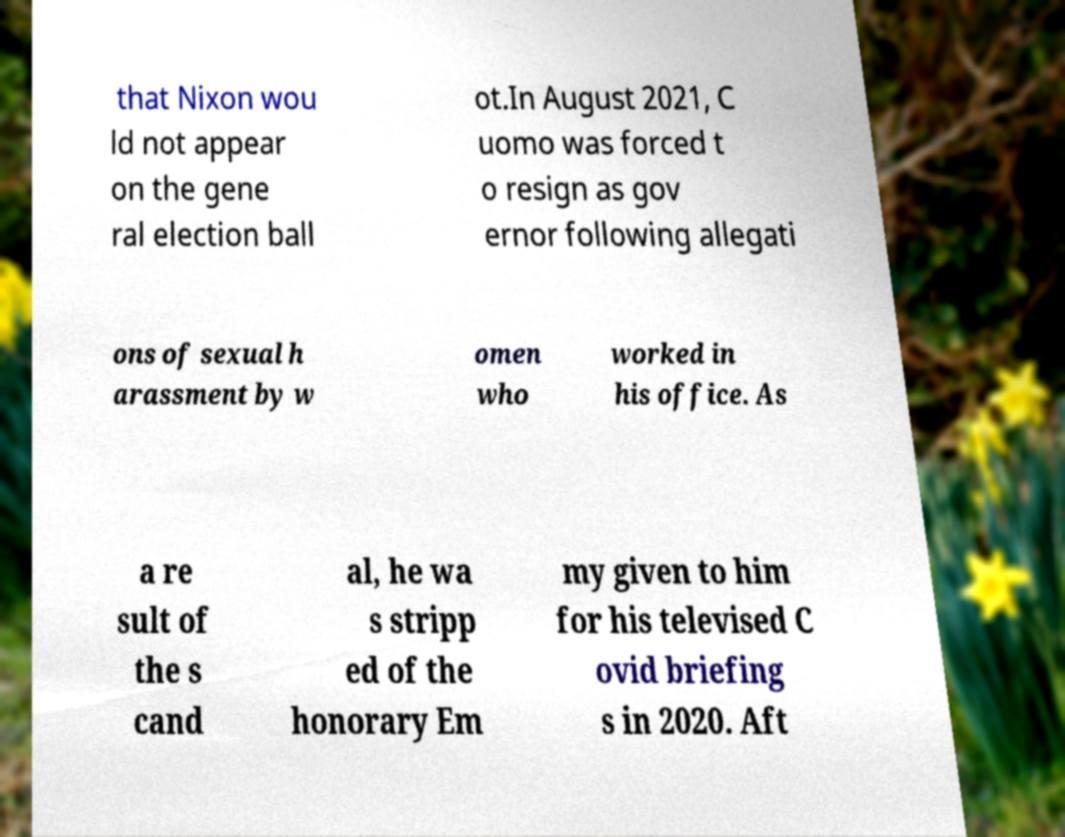Could you assist in decoding the text presented in this image and type it out clearly? that Nixon wou ld not appear on the gene ral election ball ot.In August 2021, C uomo was forced t o resign as gov ernor following allegati ons of sexual h arassment by w omen who worked in his office. As a re sult of the s cand al, he wa s stripp ed of the honorary Em my given to him for his televised C ovid briefing s in 2020. Aft 